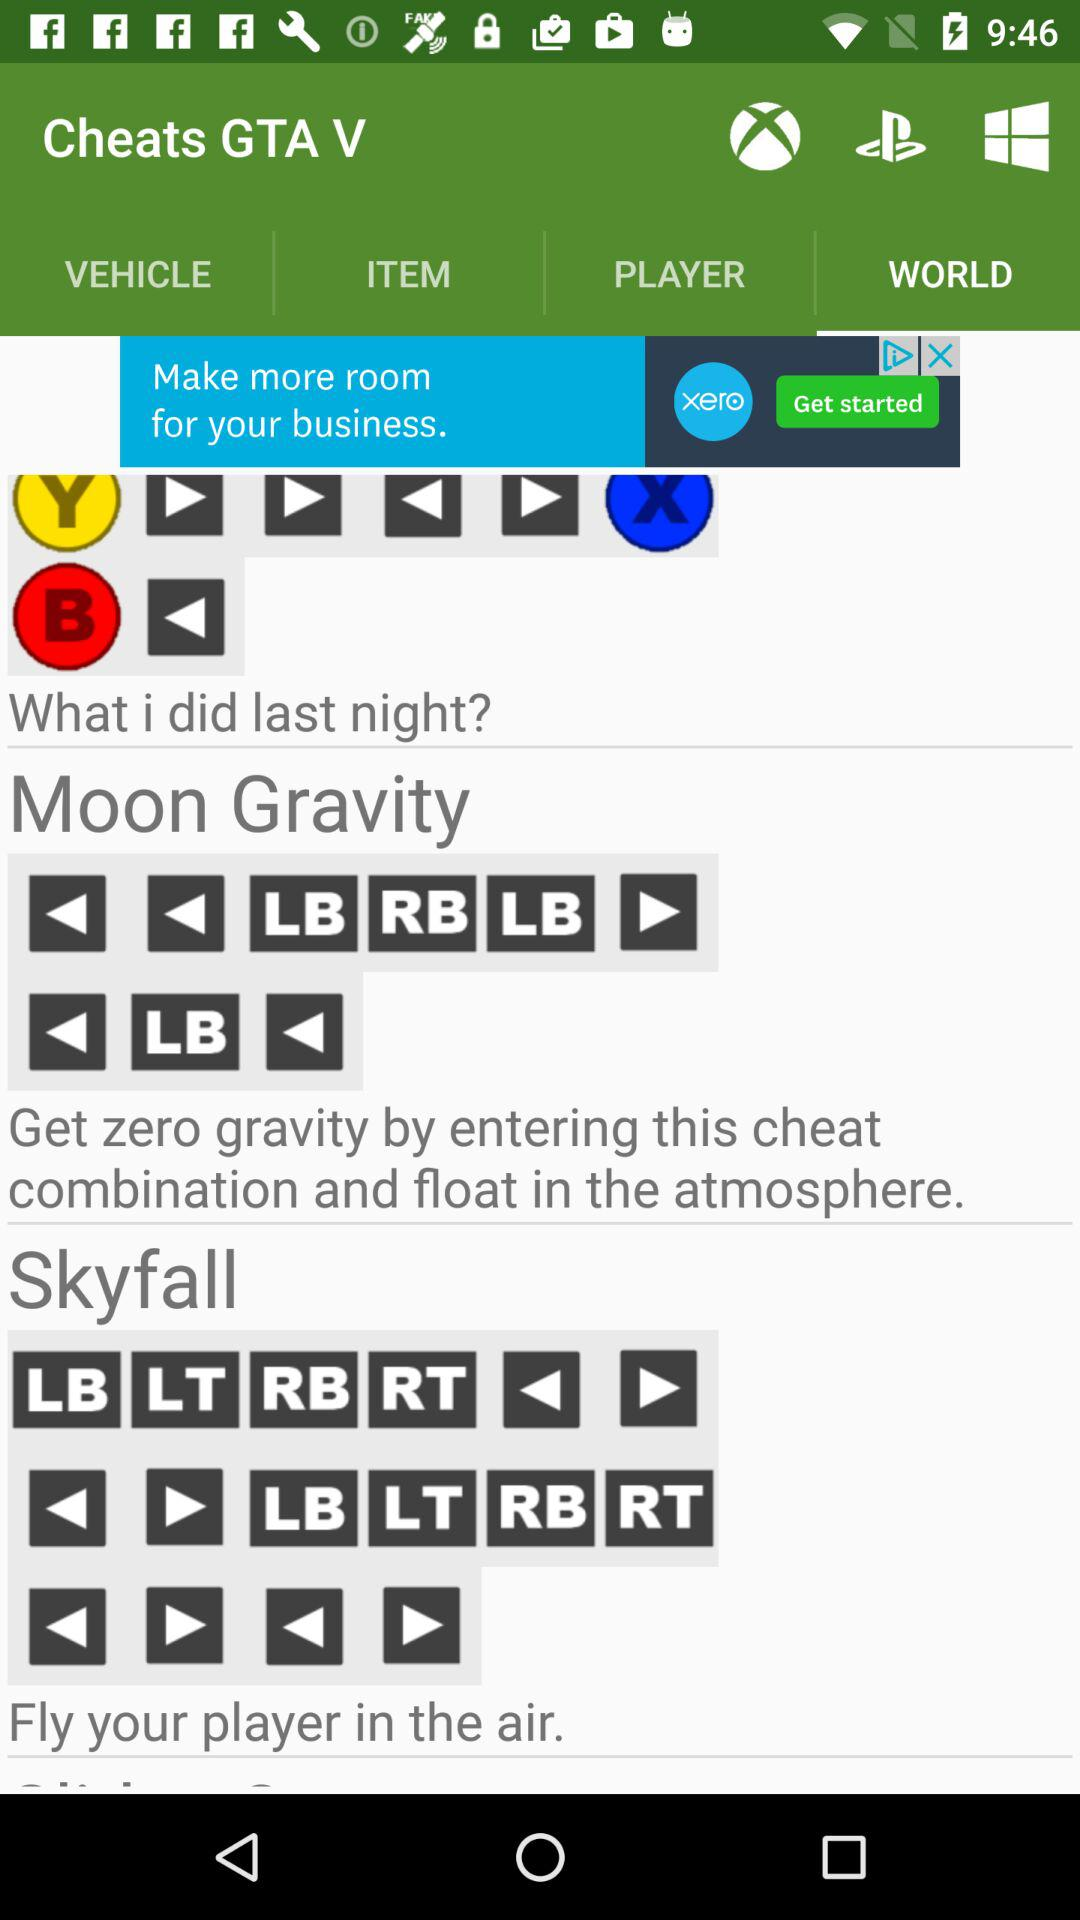Which tab am I on? You are on the "WORLD" tab. 